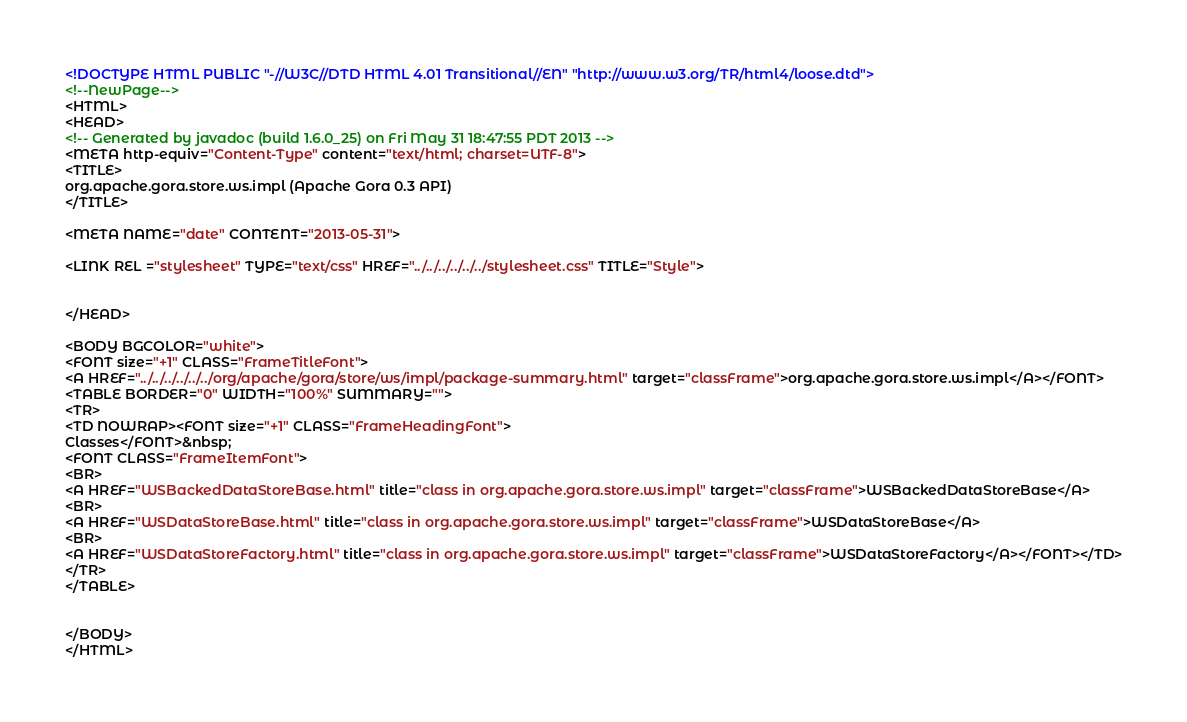Convert code to text. <code><loc_0><loc_0><loc_500><loc_500><_HTML_><!DOCTYPE HTML PUBLIC "-//W3C//DTD HTML 4.01 Transitional//EN" "http://www.w3.org/TR/html4/loose.dtd">
<!--NewPage-->
<HTML>
<HEAD>
<!-- Generated by javadoc (build 1.6.0_25) on Fri May 31 18:47:55 PDT 2013 -->
<META http-equiv="Content-Type" content="text/html; charset=UTF-8">
<TITLE>
org.apache.gora.store.ws.impl (Apache Gora 0.3 API)
</TITLE>

<META NAME="date" CONTENT="2013-05-31">

<LINK REL ="stylesheet" TYPE="text/css" HREF="../../../../../../stylesheet.css" TITLE="Style">


</HEAD>

<BODY BGCOLOR="white">
<FONT size="+1" CLASS="FrameTitleFont">
<A HREF="../../../../../../org/apache/gora/store/ws/impl/package-summary.html" target="classFrame">org.apache.gora.store.ws.impl</A></FONT>
<TABLE BORDER="0" WIDTH="100%" SUMMARY="">
<TR>
<TD NOWRAP><FONT size="+1" CLASS="FrameHeadingFont">
Classes</FONT>&nbsp;
<FONT CLASS="FrameItemFont">
<BR>
<A HREF="WSBackedDataStoreBase.html" title="class in org.apache.gora.store.ws.impl" target="classFrame">WSBackedDataStoreBase</A>
<BR>
<A HREF="WSDataStoreBase.html" title="class in org.apache.gora.store.ws.impl" target="classFrame">WSDataStoreBase</A>
<BR>
<A HREF="WSDataStoreFactory.html" title="class in org.apache.gora.store.ws.impl" target="classFrame">WSDataStoreFactory</A></FONT></TD>
</TR>
</TABLE>


</BODY>
</HTML>
</code> 